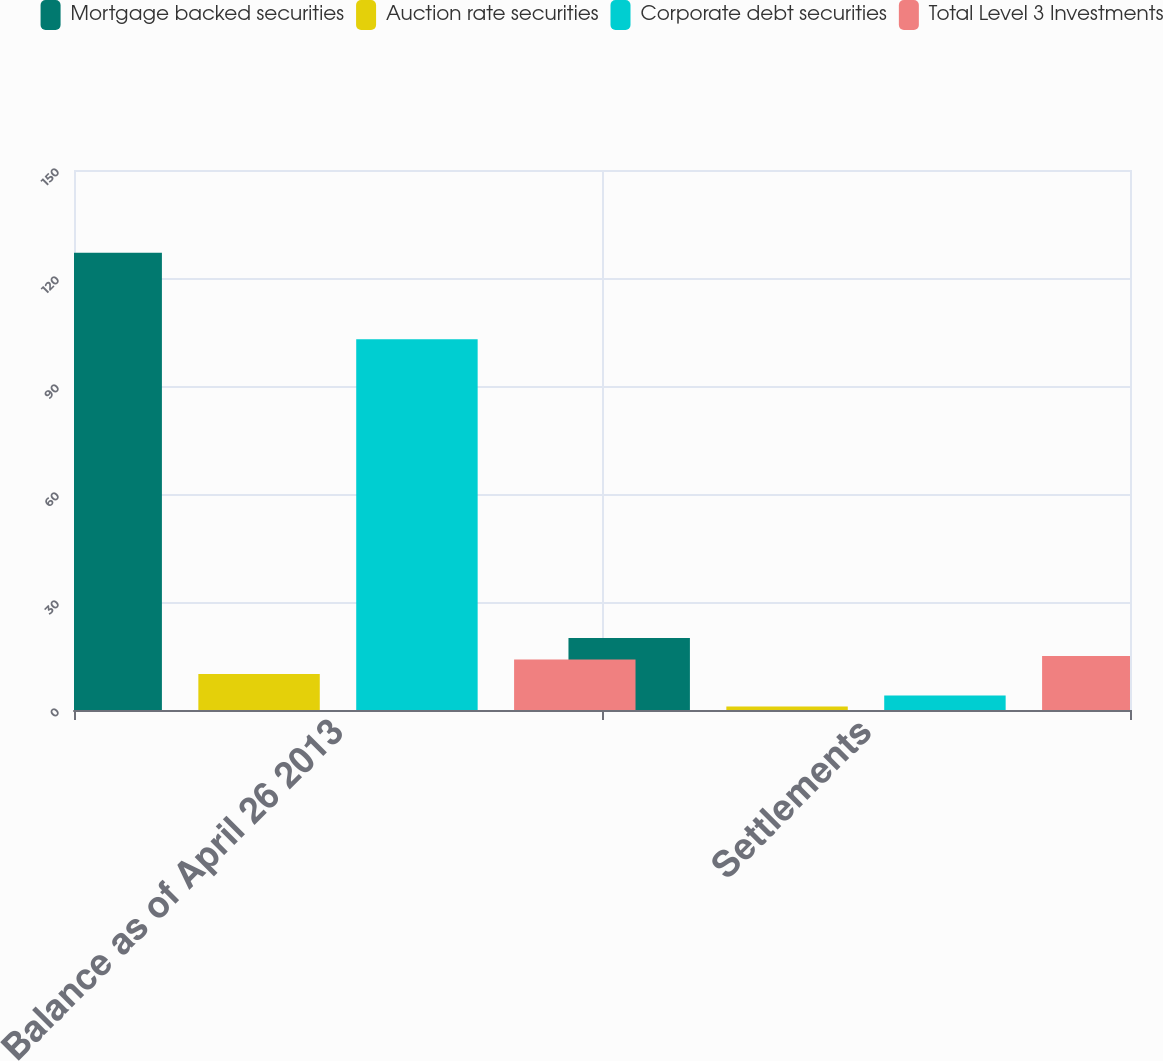Convert chart. <chart><loc_0><loc_0><loc_500><loc_500><stacked_bar_chart><ecel><fcel>Balance as of April 26 2013<fcel>Settlements<nl><fcel>Mortgage backed securities<fcel>127<fcel>20<nl><fcel>Auction rate securities<fcel>10<fcel>1<nl><fcel>Corporate debt securities<fcel>103<fcel>4<nl><fcel>Total Level 3 Investments<fcel>14<fcel>15<nl></chart> 